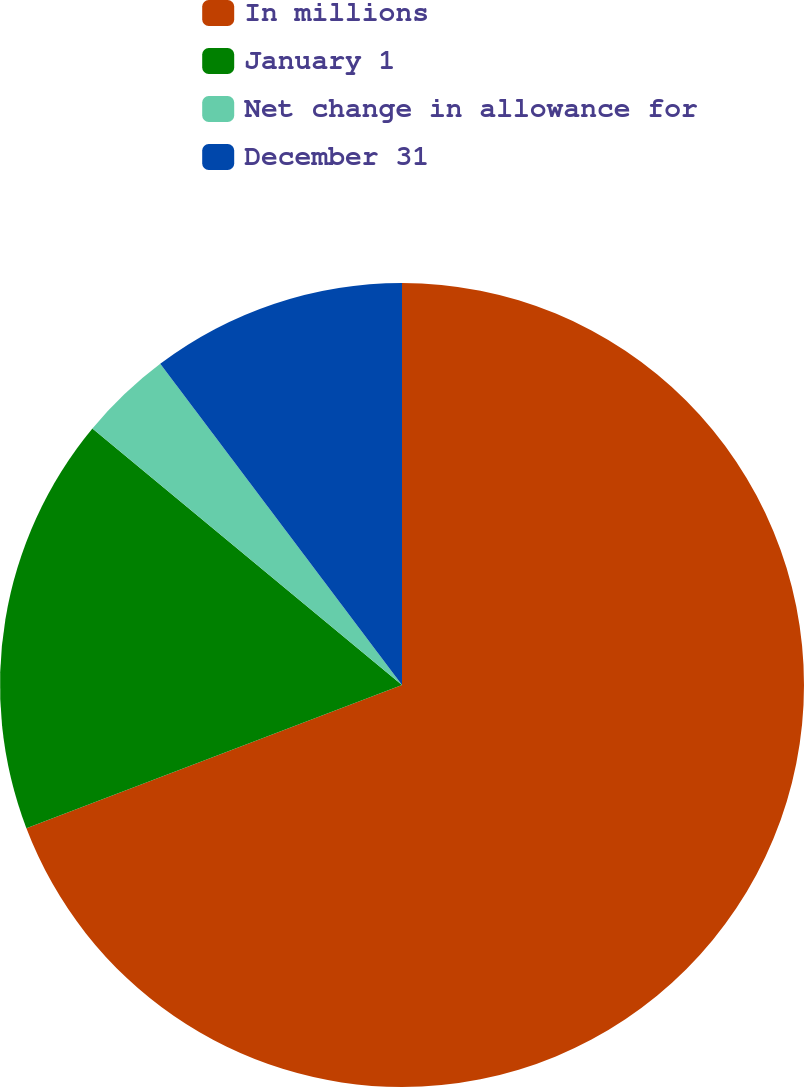<chart> <loc_0><loc_0><loc_500><loc_500><pie_chart><fcel>In millions<fcel>January 1<fcel>Net change in allowance for<fcel>December 31<nl><fcel>69.2%<fcel>16.81%<fcel>3.72%<fcel>10.27%<nl></chart> 